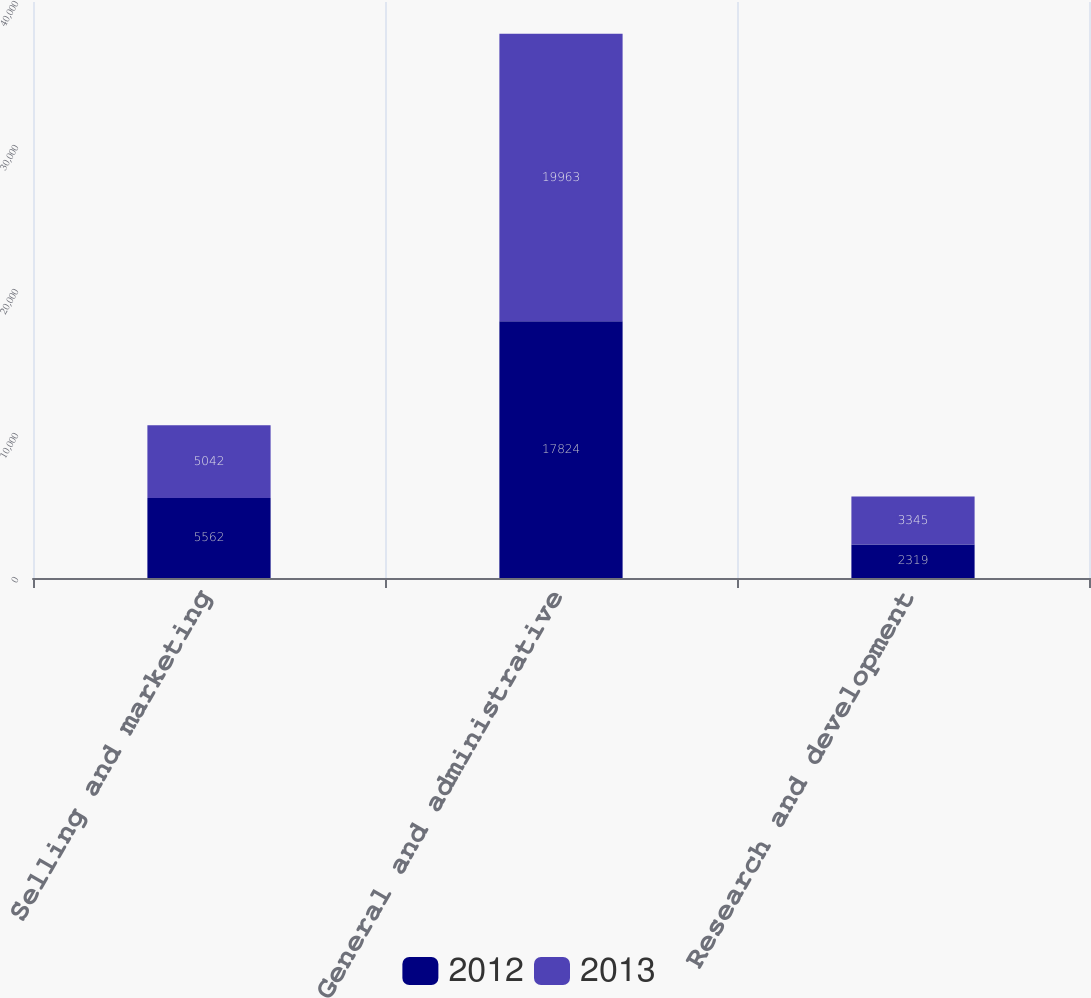Convert chart to OTSL. <chart><loc_0><loc_0><loc_500><loc_500><stacked_bar_chart><ecel><fcel>Selling and marketing<fcel>General and administrative<fcel>Research and development<nl><fcel>2012<fcel>5562<fcel>17824<fcel>2319<nl><fcel>2013<fcel>5042<fcel>19963<fcel>3345<nl></chart> 